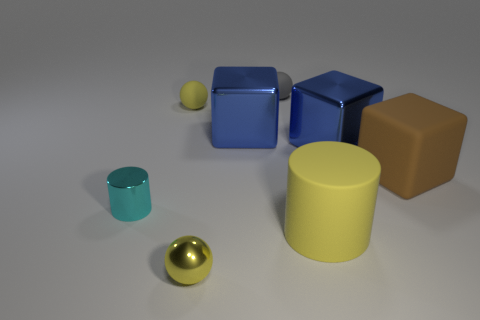Subtract all cyan cylinders. How many blue blocks are left? 2 Add 1 large yellow cylinders. How many objects exist? 9 Subtract all cylinders. How many objects are left? 6 Subtract all big brown metallic objects. Subtract all big metal objects. How many objects are left? 6 Add 5 yellow metallic objects. How many yellow metallic objects are left? 6 Add 7 large cubes. How many large cubes exist? 10 Subtract 0 gray blocks. How many objects are left? 8 